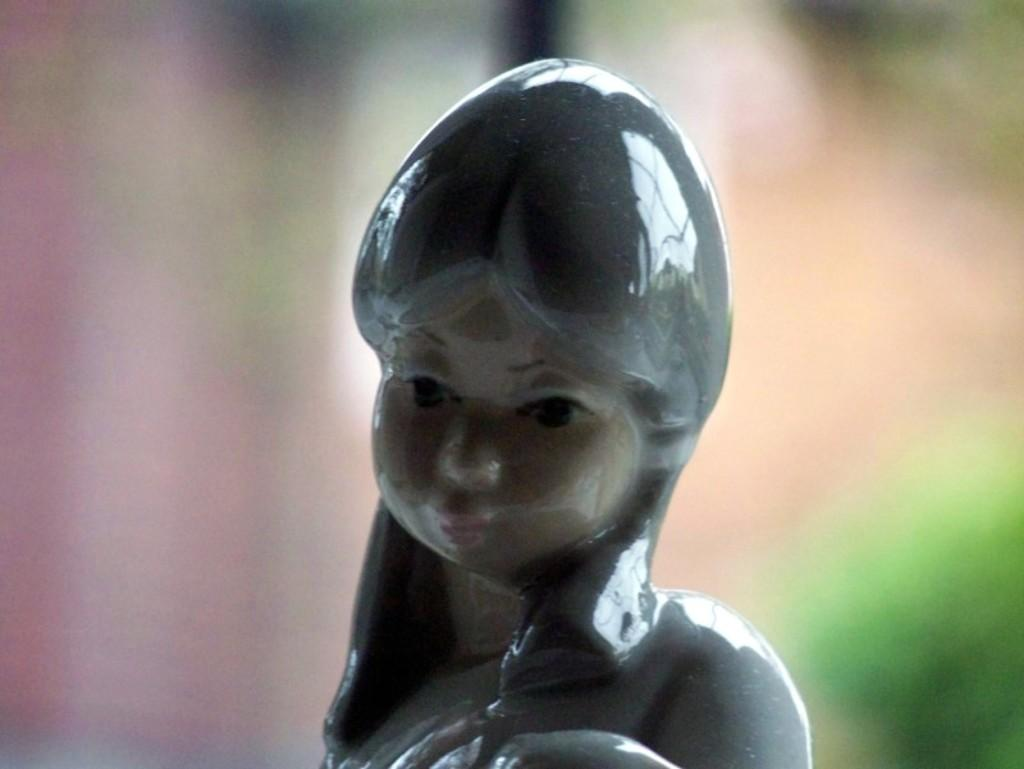What is the main subject of the image? There is a ceramic sculpture of a woman in the image. Can you describe the background of the image? The background of the image appears blurry. What type of credit can be seen on the sculpture in the image? There is no credit visible on the sculpture in the image. What is the oatmeal's role in the image? There is no oatmeal present in the image. 